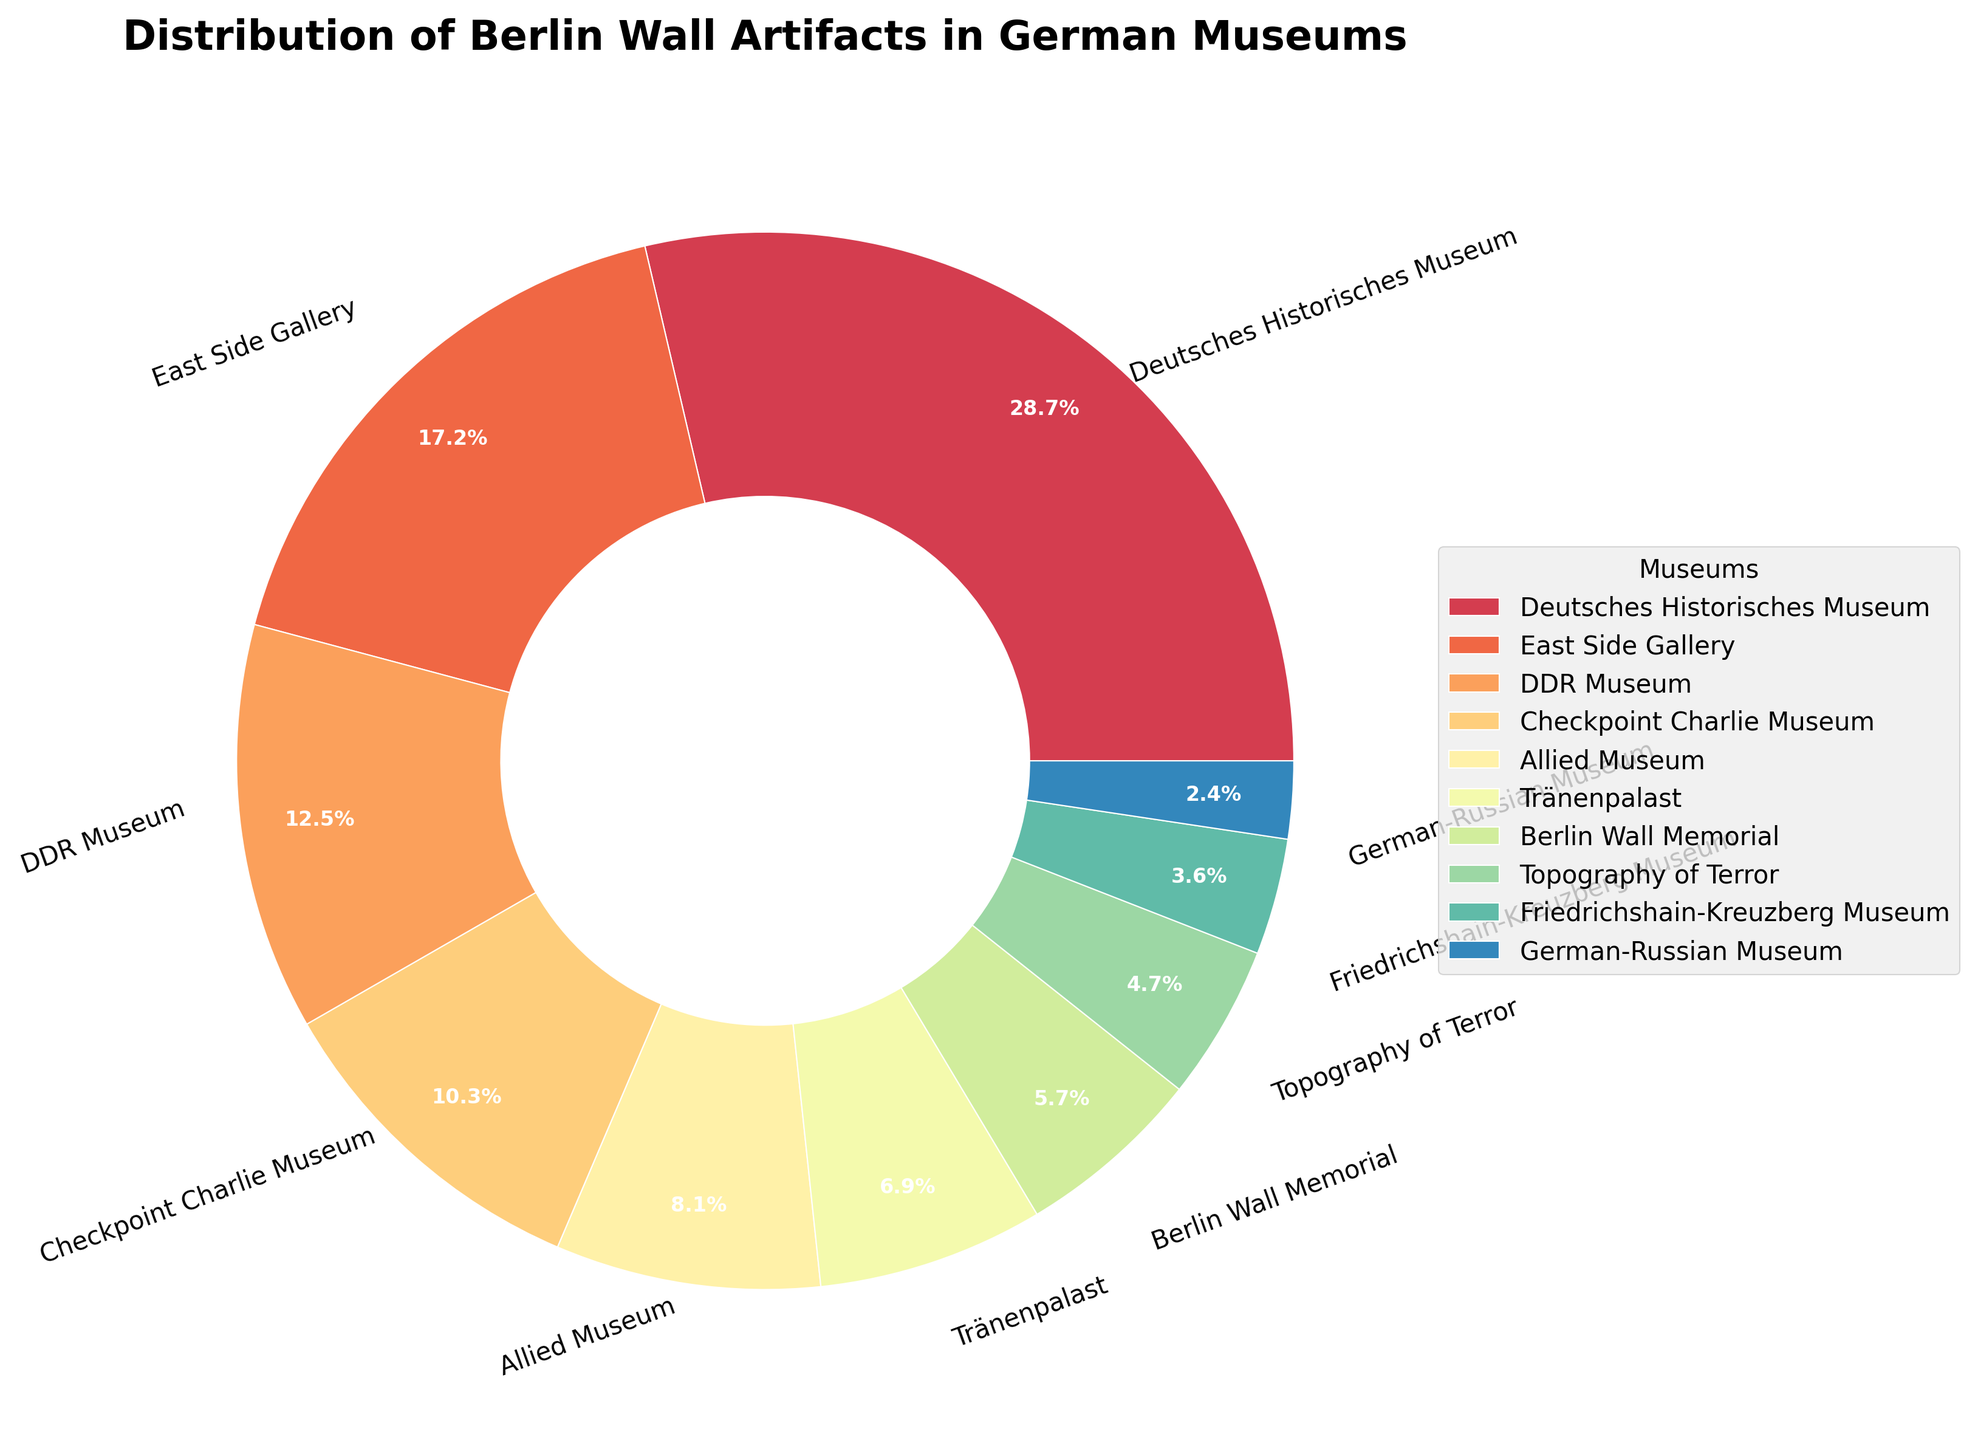How many total artifacts are distributed among all the museums? Add the number of artifacts in each museum (145 + 87 + 63 + 52 + 41 + 35 + 29 + 24 + 18 + 12), which totals to 506.
Answer: 506 What percentage of the total artifacts does the Deutsches Historisches Museum hold? The Deutsches Historisches Museum has 145 artifacts. The total number of artifacts is 506. So, the percentage is (145/506) * 100 ≈ 28.7%.
Answer: 28.7% Is there any museum that has fewer artifacts than the Berlin Wall Memorial but more than the German-Russian Museum? Yes, the Topography of Terror Museum has 24 artifacts, which is more than the German-Russian Museum's 12 artifacts but fewer than the Berlin Wall Memorial's 29 artifacts.
Answer: Yes, Topography of Terror Which museum has the least number of artifacts? The museum with the smallest slice in the pie chart is the German-Russian Museum, with 12 artifacts.
Answer: German-Russian Museum Does the DDR Museum have more artifacts than the Allied Museum and Tränenpalast combined? The DDR Museum has 63 artifacts. The Allied Museum and Tränenpalast together have 41 + 35 = 76 artifacts, which is more than 63.
Answer: No Which museums together have about half of the total artifacts? Deutsches Historisches Museum (145) and East Side Gallery (87). Their sum is 145 + 87 = 232, which is approximately 50% of the total 506 artifacts.
Answer: Deutsches Historisches Museum and East Side Gallery How do the artifact counts compare between the Museum with the second-highest number and the Museum with the third-highest number? The East Side Gallery has 87 artifacts, and the DDR Museum has 63 artifacts. So, the East Side Gallery has 24 more artifacts than the DDR Museum.
Answer: East Side Gallery has 24 more What fraction of the total artifacts are found in the Checkpoint Charlie Museum? Checkpoint Charlie Museum holds 52 artifacts out of a total of 506. So, the fraction is 52/506, which simplifies approximately to 1/10.
Answer: 1/10 How many museums have more than 40 artifacts but less than 100? East Side Gallery (87), DDR Museum (63), Checkpoint Charlie Museum (52), and Allied Museum (41). This makes a total of 4 museums.
Answer: 4 